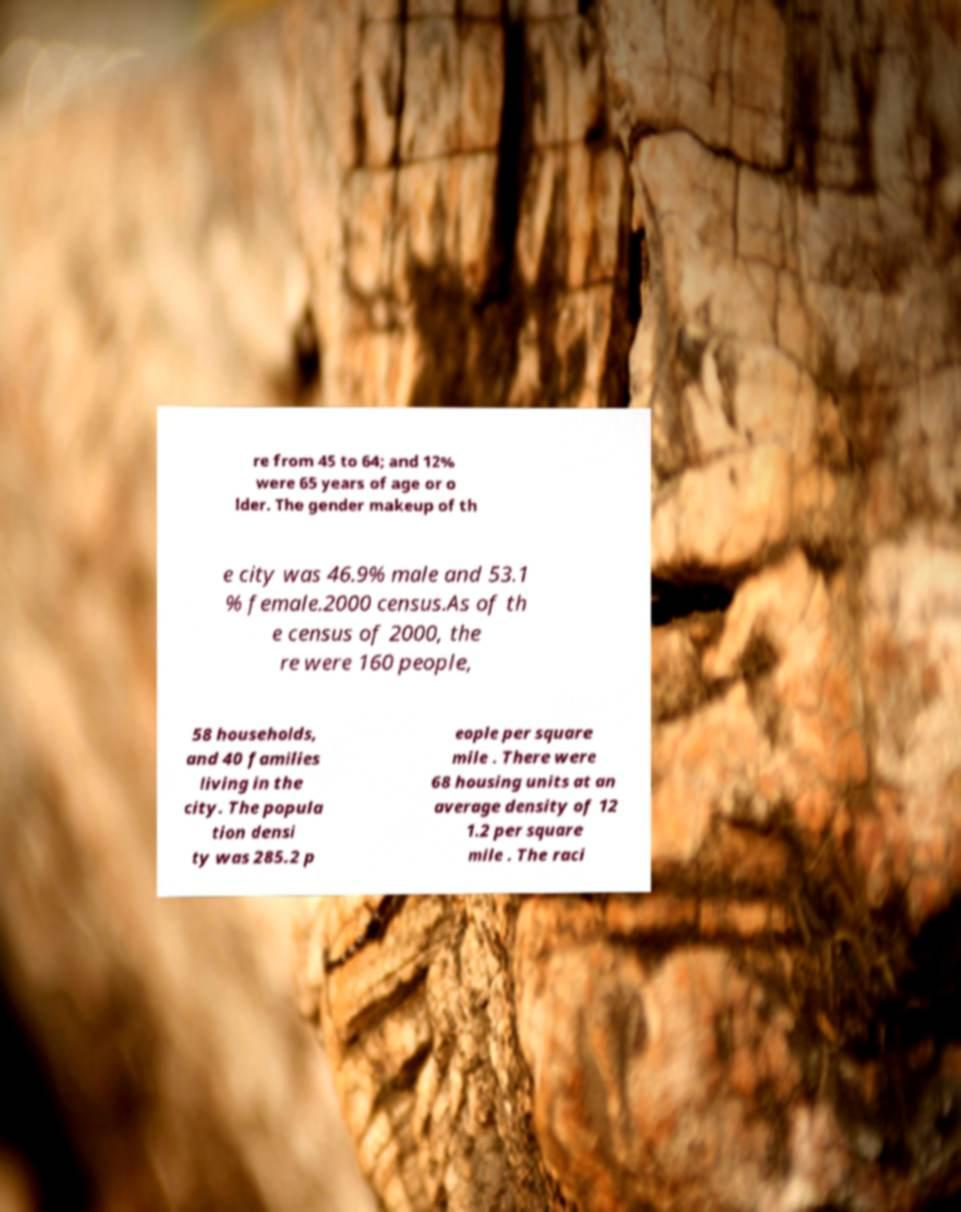Could you extract and type out the text from this image? re from 45 to 64; and 12% were 65 years of age or o lder. The gender makeup of th e city was 46.9% male and 53.1 % female.2000 census.As of th e census of 2000, the re were 160 people, 58 households, and 40 families living in the city. The popula tion densi ty was 285.2 p eople per square mile . There were 68 housing units at an average density of 12 1.2 per square mile . The raci 